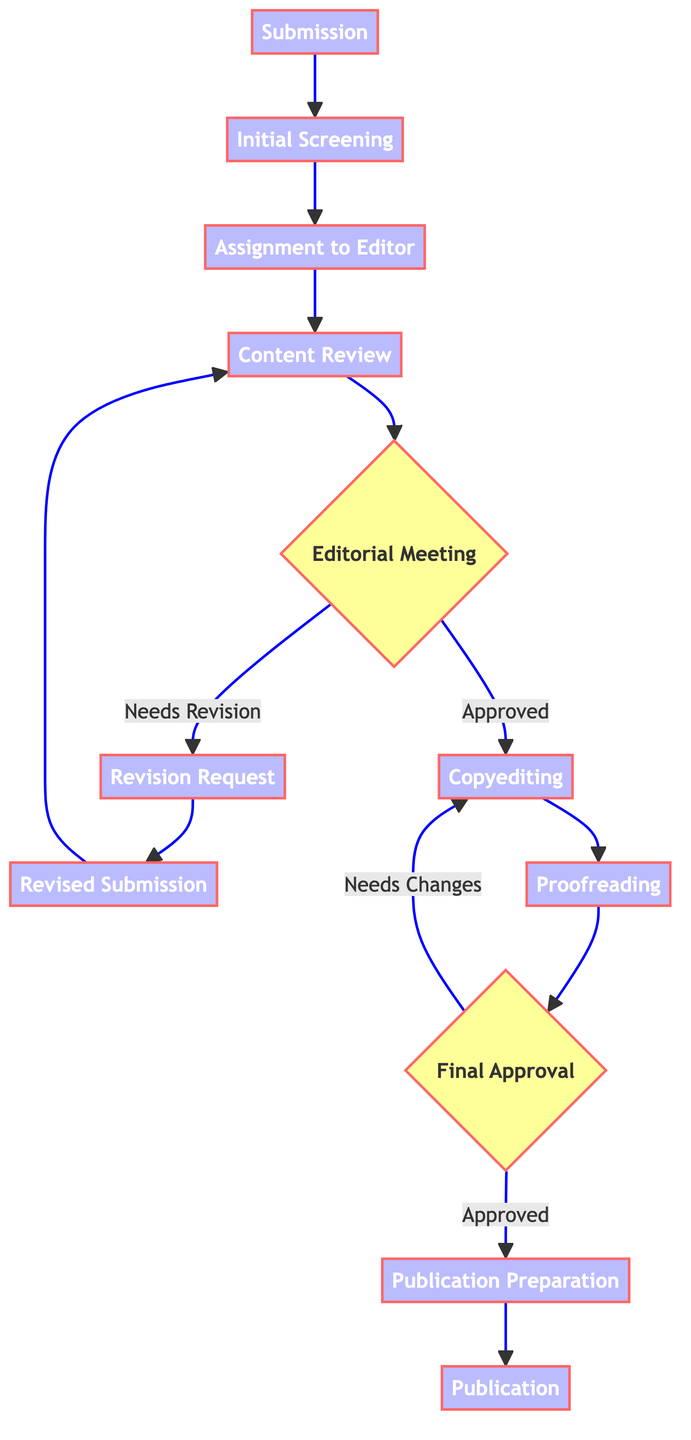What is the first step in the editorial review process? The first step is "Submission," where the sci-fi manuscript is submitted by the author to the publishing house.
Answer: Submission How many steps are there in the process from submission to publication? There are 12 steps in total, starting from "Submission" and ending with "Publication."
Answer: 12 Which node indicates a decision-making point? The decision-making points in the diagram are labeled as "Editorial Meeting" and "Final Approval."
Answer: Editorial Meeting, Final Approval What does the "Revision Request" node lead to? The "Revision Request" node leads to the "Revised Submission" node, indicating that the author needs to revise the manuscript.
Answer: Revised Submission What happens after the "Copyediting" node? After the "Copyediting" node, the process moves to the "Proofreading" node, which involves checking the manuscript for remaining errors.
Answer: Proofreading If "Final Approval" is not given, where does the process go? If "Final Approval" is not given, the process returns to the "Copyediting" node for further changes.
Answer: Copyediting Which step requires the author to take further action? The "Revision Request" step requires the author to revise the manuscript based on feedback provided.
Answer: Revision Request What is the last step in the process? The last step in the process is "Publication," where the manuscript is published and made available to the public.
Answer: Publication What step follows the "Content Review"? After "Content Review," the manuscript moves to the "Editorial Meeting" for feedback and approval from the editorial board.
Answer: Editorial Meeting What happens if the editorial board approves the manuscript? If the editorial board approves the manuscript during the "Editorial Meeting," it goes to the "Copyediting" step for further refinement.
Answer: Copyediting 